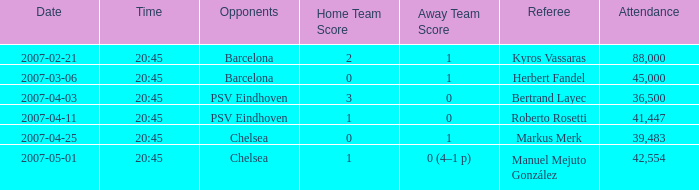Which competitor initiated a match on 2007-03-06, 20:45? Barcelona. 